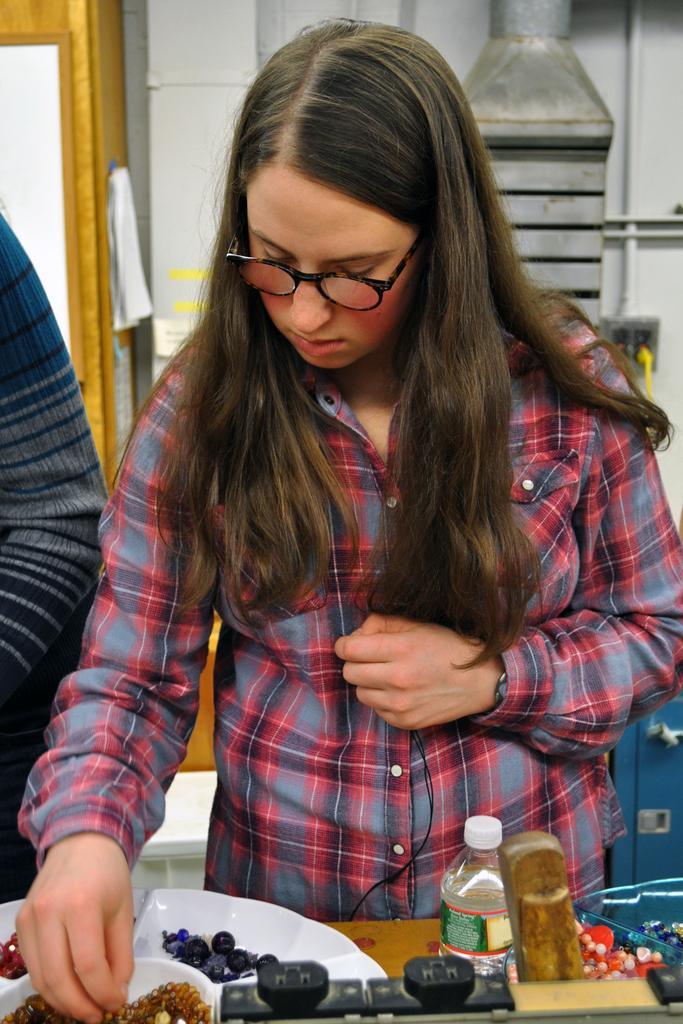Can you describe this image briefly? In this picture i can see a woman and a person. The woman is wearing spectacles and shirt. On the table i can see bottle, white color objects and food items. In the background i can see wall and other objects. 